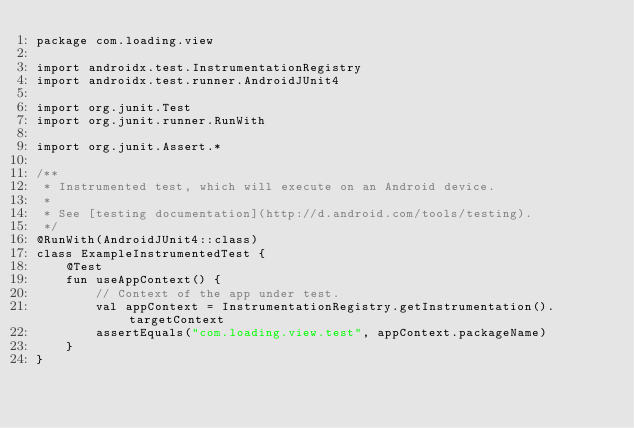<code> <loc_0><loc_0><loc_500><loc_500><_Kotlin_>package com.loading.view

import androidx.test.InstrumentationRegistry
import androidx.test.runner.AndroidJUnit4

import org.junit.Test
import org.junit.runner.RunWith

import org.junit.Assert.*

/**
 * Instrumented test, which will execute on an Android device.
 *
 * See [testing documentation](http://d.android.com/tools/testing).
 */
@RunWith(AndroidJUnit4::class)
class ExampleInstrumentedTest {
    @Test
    fun useAppContext() {
        // Context of the app under test.
        val appContext = InstrumentationRegistry.getInstrumentation().targetContext
        assertEquals("com.loading.view.test", appContext.packageName)
    }
}</code> 